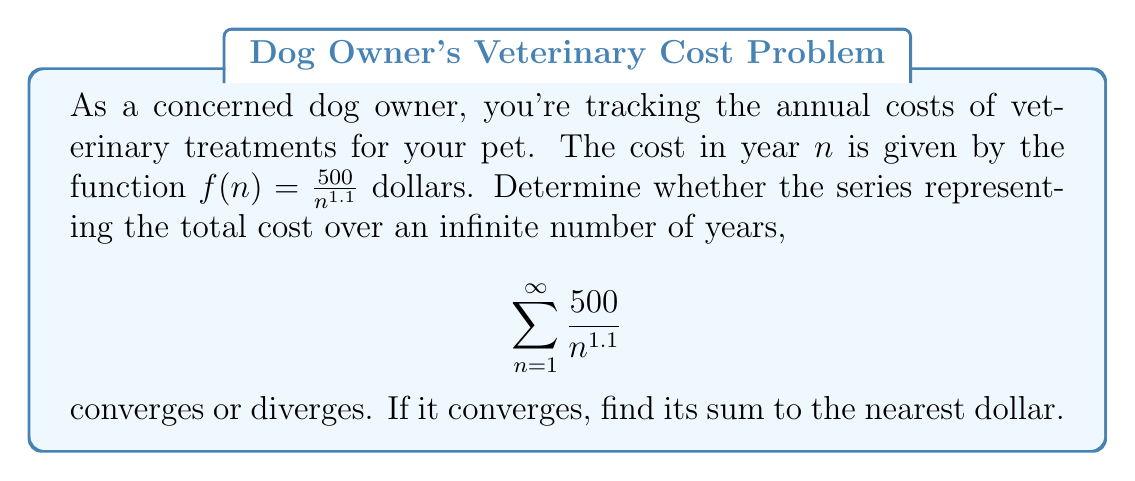Can you answer this question? Let's approach this step-by-step:

1) First, we need to recognize that this is a p-series of the form $\sum_{n=1}^{\infty} \frac{1}{n^p}$, where $p = 1.1$ and there's a constant factor of 500.

2) For a p-series:
   - If $p > 1$, the series converges
   - If $p \leq 1$, the series diverges

3) In our case, $p = 1.1 > 1$, so the series converges.

4) To find the sum, we can use the fact that for a p-series $\sum_{n=1}^{\infty} \frac{1}{n^p}$ with $p > 1$, the sum is approximately:

   $$\zeta(p) + \frac{1}{(p-1)} - \frac{1}{2} + \frac{p}{12} - \frac{p(p-1)(p-2)}{120}$$

   where $\zeta(p)$ is the Riemann zeta function.

5) For $p = 1.1$:
   $\zeta(1.1) \approx 10.5844$

6) Plugging in $p = 1.1$ to the formula:

   $10.5844 + \frac{1}{0.1} - \frac{1}{2} + \frac{1.1}{12} - \frac{1.1(0.1)(-0.9)}{120} \approx 20.5844$

7) Multiply this by 500 to account for the constant factor:

   $500 * 20.5844 = 10,292.2$

8) Rounding to the nearest dollar: $10,292
Answer: The series converges, with a sum of approximately $10,292. 